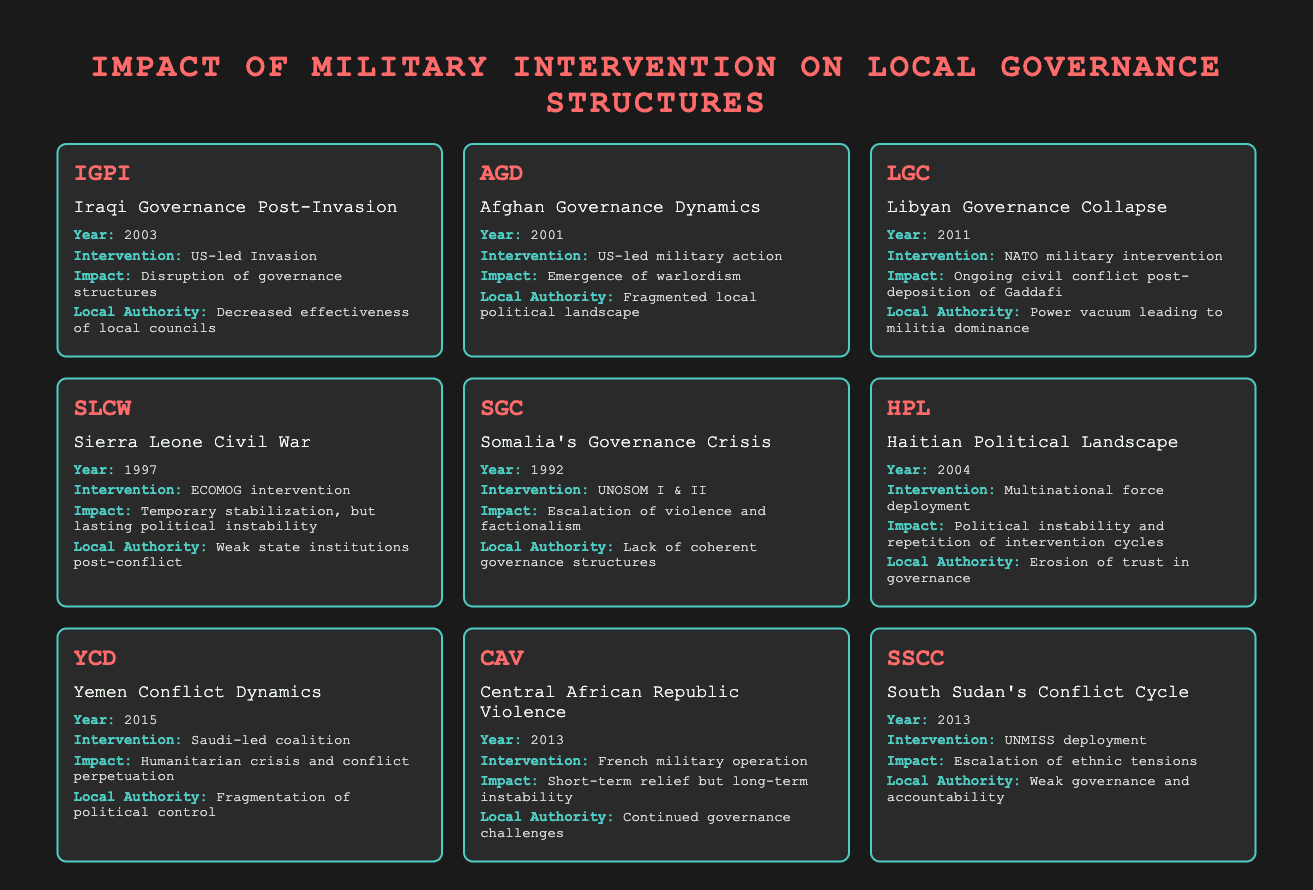What year did the US-led invasion of Iraq occur? The table identifies Iraqi Governance Post-Invasion with a data point indicating "Year: 2003."
Answer: 2003 Which intervention is associated with the emergence of warlordism in Afghanistan? The table shows "Afghan Governance Dynamics" mentions the "Intervention: US-led military action," which correlates with the noted emergence of warlordism.
Answer: US-led military action What impact did the NATO military intervention have on Libya? According to the entry for Libyan Governance Collapse, the impact mentioned is "Ongoing civil conflict post-deposition of Gaddafi."
Answer: Ongoing civil conflict post-deposition of Gaddafi Were local authorities in Sierra Leone strengthened after the ECOMOG intervention? The data for Sierra Leone states "Local Authority: Weak state institutions post-conflict," indicating a negative effect on local authorities.
Answer: No What is the common consequence of military interventions in the cases of Iraq, Libya, and Yemen? Reviewing the impacts listed for Iraq, Libya, and Yemen reveals that each shows a result of governance disruption or ongoing conflict, suggesting a pattern of instability.
Answer: Instability and conflict Which two interventions led to reduced effectiveness of local councils or governance structures? The interventions for Iraq (US-led Invasion) and Haiti (Multinational force deployment) both show patterns tied to decreased effectiveness of local governance.
Answer: US-led Invasion and Multinational force deployment In what year did the UNMISS deployment occur in South Sudan? The table states the year associated with "South Sudan's Conflict Cycle" is 2013, linked to the UNMISS deployment.
Answer: 2013 How many examples in the table mention the emergence of political instability following military intervention? By counting the entries, we find those related to Iraq, Sierra Leone, Haiti, Libya, and Yemen indicate varying degrees of political instability or related issues, leading to a total of 5 examples.
Answer: 5 examples Did the intervention in the Central African Republic lead to long-term stability? The entry for Central African Republic Violence indicates "Short-term relief but long-term instability," clearly stating the negative outcome.
Answer: No 